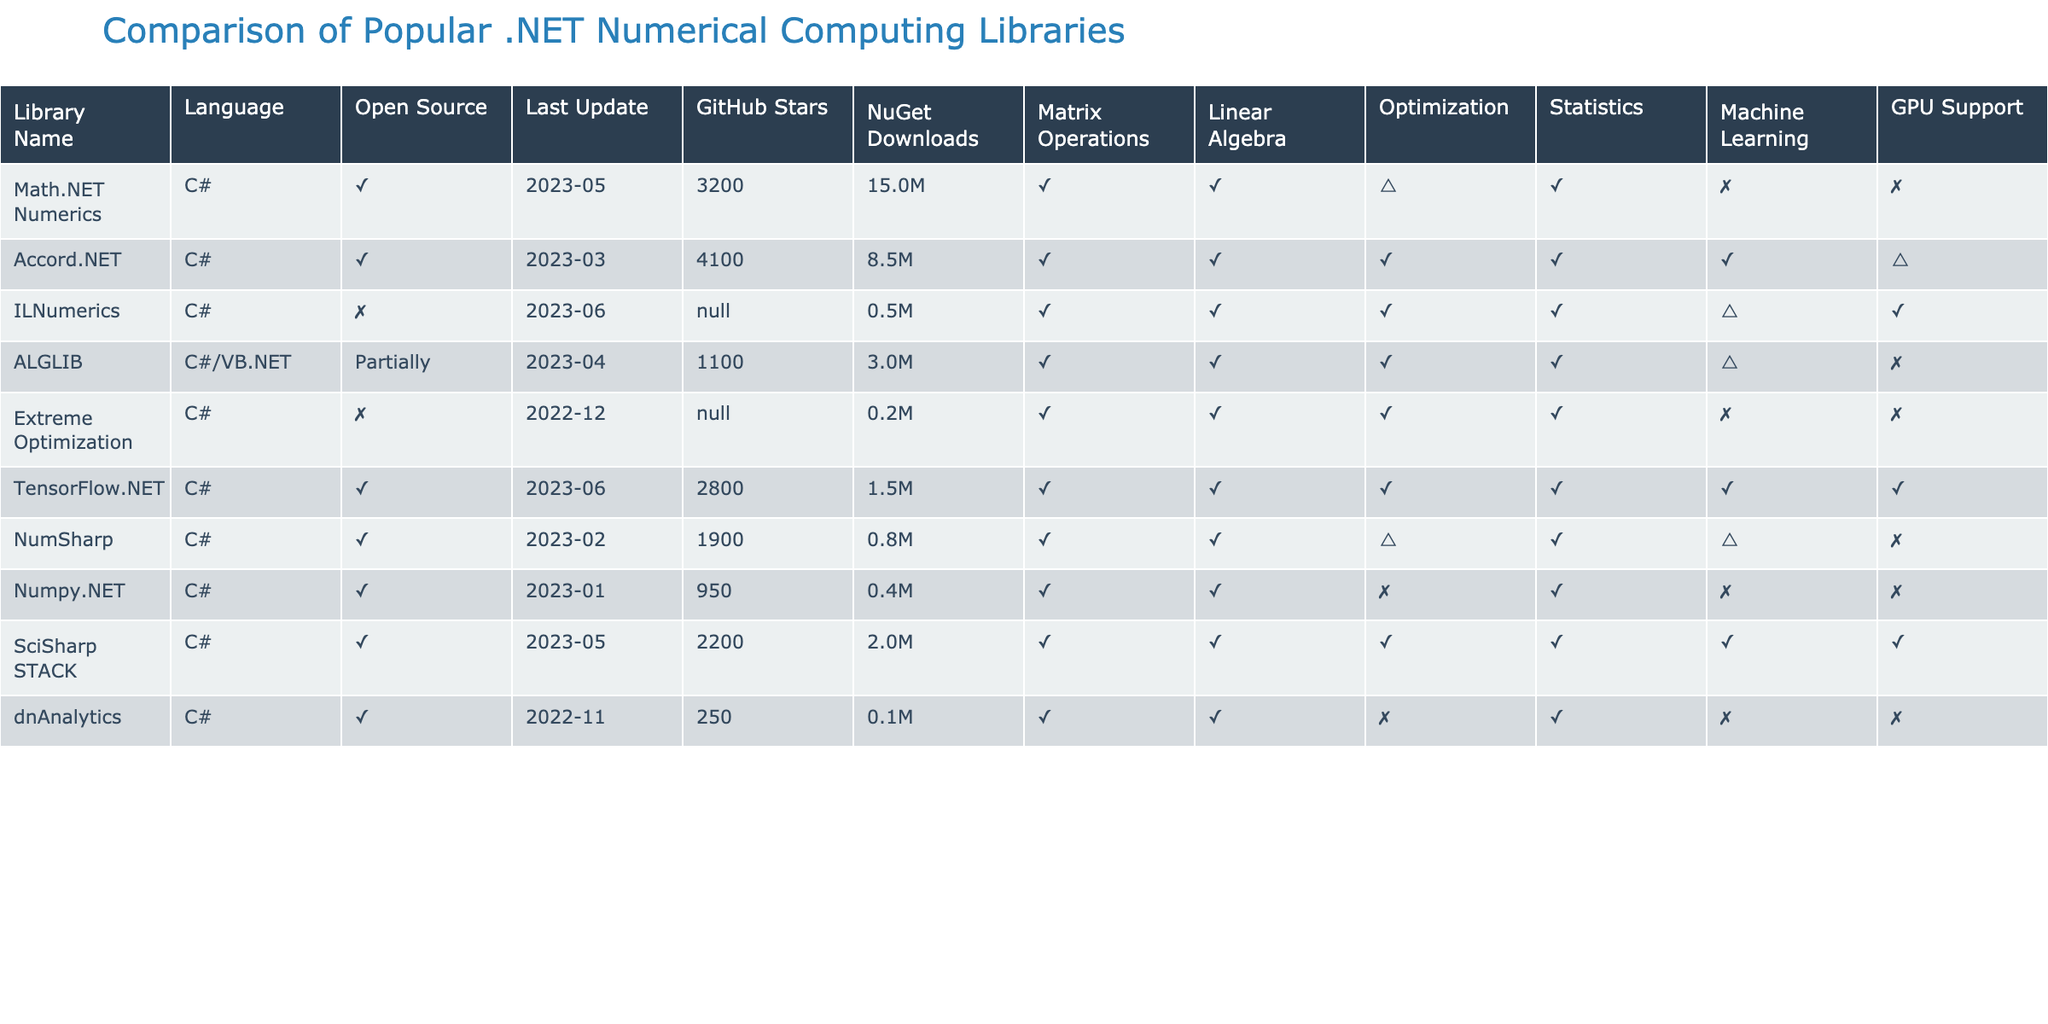What is the main programming language used by the libraries in the table? All the libraries listed in the table are primarily developed in C#, as indicated in the "Language" column.
Answer: C# Which library has the most GitHub stars? By looking through the "GitHub Stars" column and comparing the values, Accord.NET has 4100 stars, which is the highest among the listed libraries.
Answer: Accord.NET How many libraries offer GPU support? The libraries with GPU support are: ILNumerics, TensorFlow.NET, SciSharp STACK. This gives us a total of 3 libraries offering GPU support.
Answer: 3 What is the difference in NuGet downloads between Math.NET Numerics and NumSharp? Math.NET Numerics has 15000000 downloads, while NumSharp has 750000. The difference is 15000000 - 750000 = 14250000.
Answer: 14250000 Is there any library that supports all areas listed (Matrix Operations, Linear Algebra, Optimization, Statistics, Machine Learning)? By checking each library's columns, ILNumerics and TensorFlow.NET are the only ones that support all areas with no limitations.
Answer: Yes Which library received the last update most recently? By examining the "Last Update" column, ILNumerics was last updated in June 2023, making it the most recently updated library.
Answer: ILNumerics How many libraries are open source and have optimization capabilities? The open-source libraries with optimization capabilities are Accord.NET, ILNumerics, ALGLIB, Extreme Optimization, TensorFlow.NET, and SciSharp STACK. Hence, there are 6 such libraries.
Answer: 6 Which library has limited support in Machine Learning and Statistics? Looking at the "Machine Learning" and "Statistics" columns, NumSharp has limited support in both areas.
Answer: NumSharp What is the average number of NuGet downloads for the libraries? The total NuGet downloads from the chart are 15000000 + 8500000 + 500000 + 3000000 + 200000 + 1500000 + 750000 + 400000 + 2000000 + 100000 = 30350000. There are 10 libraries, so the average is 30350000 / 10 = 3035000.
Answer: 3035000 